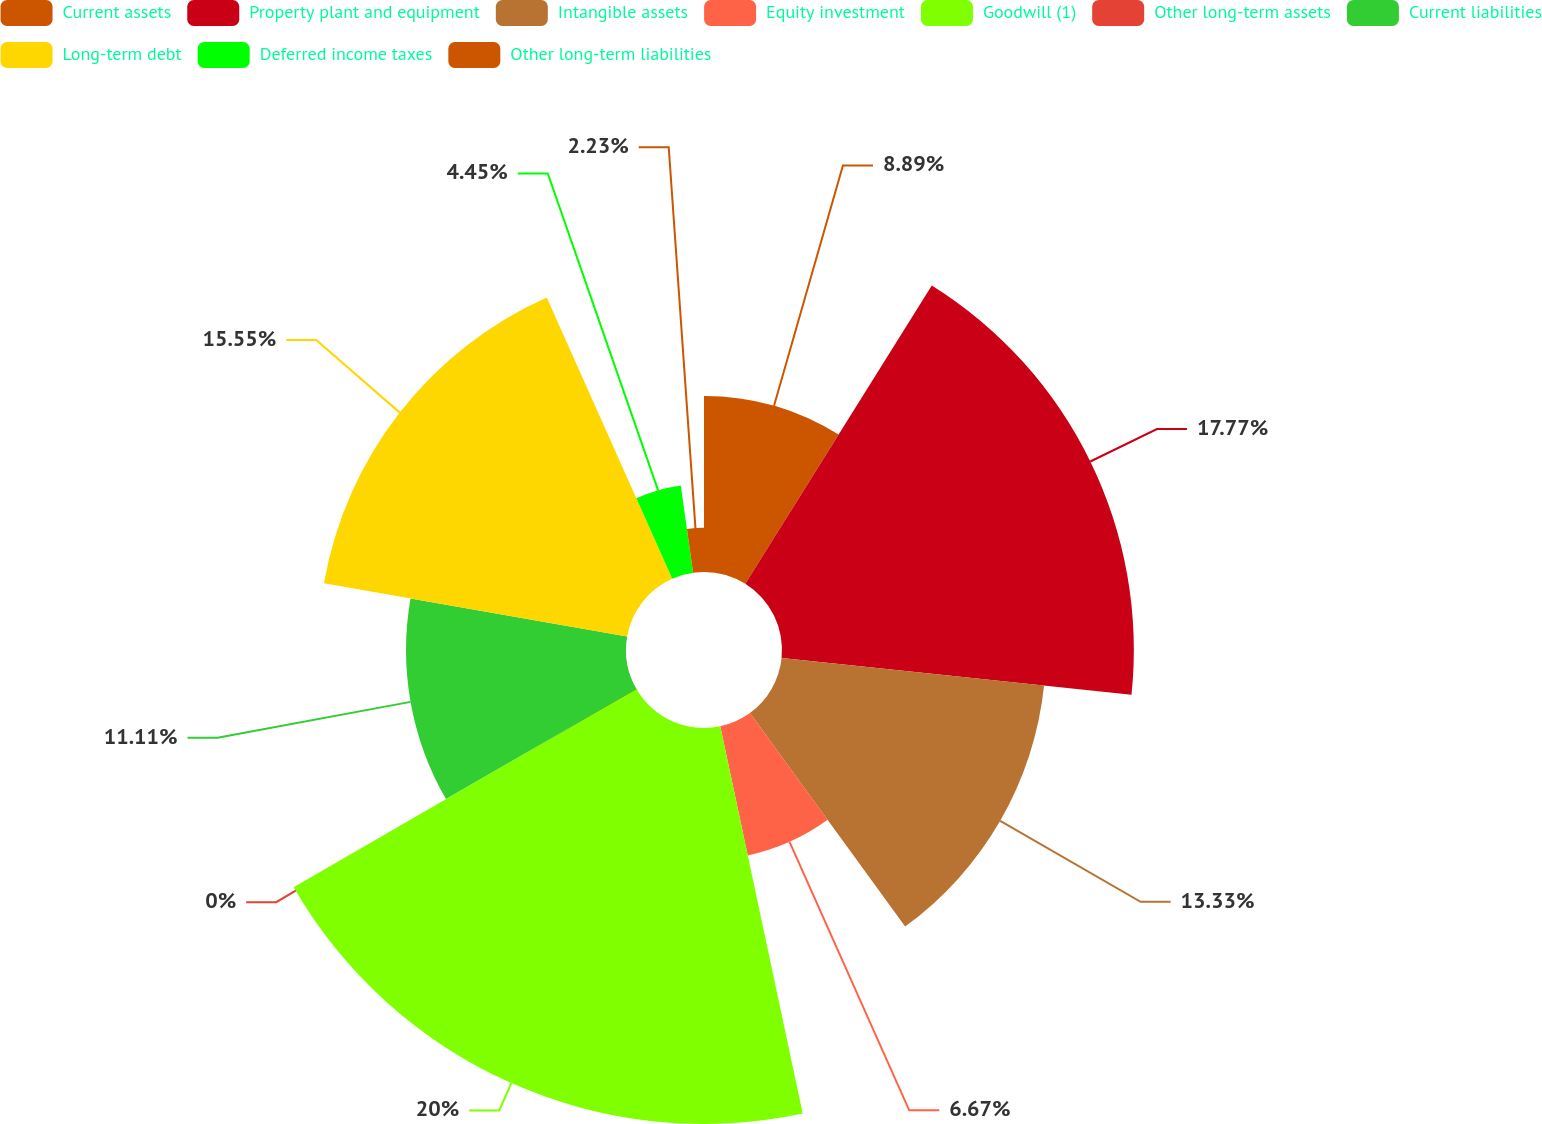Convert chart. <chart><loc_0><loc_0><loc_500><loc_500><pie_chart><fcel>Current assets<fcel>Property plant and equipment<fcel>Intangible assets<fcel>Equity investment<fcel>Goodwill (1)<fcel>Other long-term assets<fcel>Current liabilities<fcel>Long-term debt<fcel>Deferred income taxes<fcel>Other long-term liabilities<nl><fcel>8.89%<fcel>17.77%<fcel>13.33%<fcel>6.67%<fcel>20.0%<fcel>0.0%<fcel>11.11%<fcel>15.55%<fcel>4.45%<fcel>2.23%<nl></chart> 